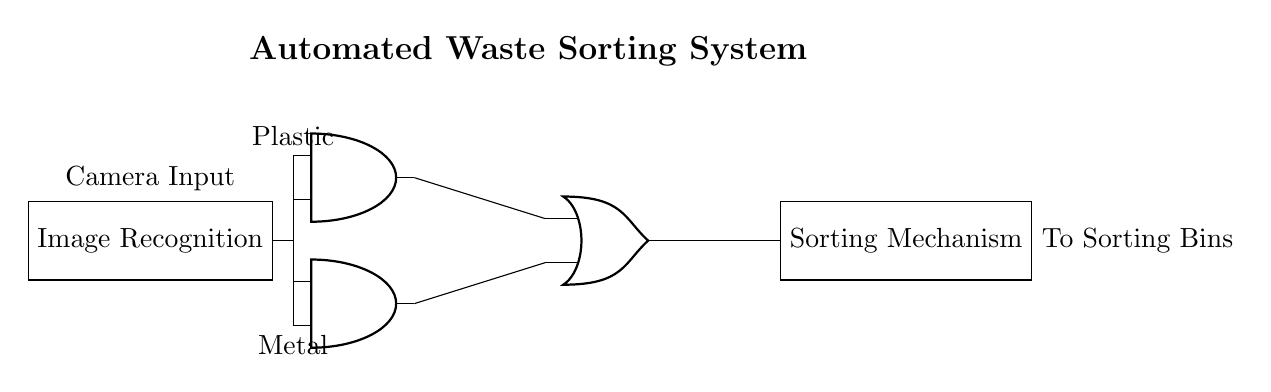What is the primary function of the image recognition component? The primary function is to identify and classify the type of waste material based on the images captured.
Answer: Identify waste What types of materials does the system sort? The system sorts plastic and metal waste, as indicated by the inputs to the logic gates.
Answer: Plastic and metal How many logic gates are used in this circuit? There are two AND gates and one OR gate, totaling three logic gates.
Answer: Three What does the output of the OR gate control? The output of the OR gate controls the sorting mechanism, which directs the sorted waste to the appropriate bins.
Answer: Sorting mechanism What is the role of the AND gates in this circuit? The AND gates are used to process the signals from the image recognition component to determine if the detected waste matches either plastic or metal criteria.
Answer: Process signals What triggers the sorting mechanism? The sorting mechanism is triggered by the output of the OR gate, which consolidates the results from both AND gates.
Answer: Output of OR gate 